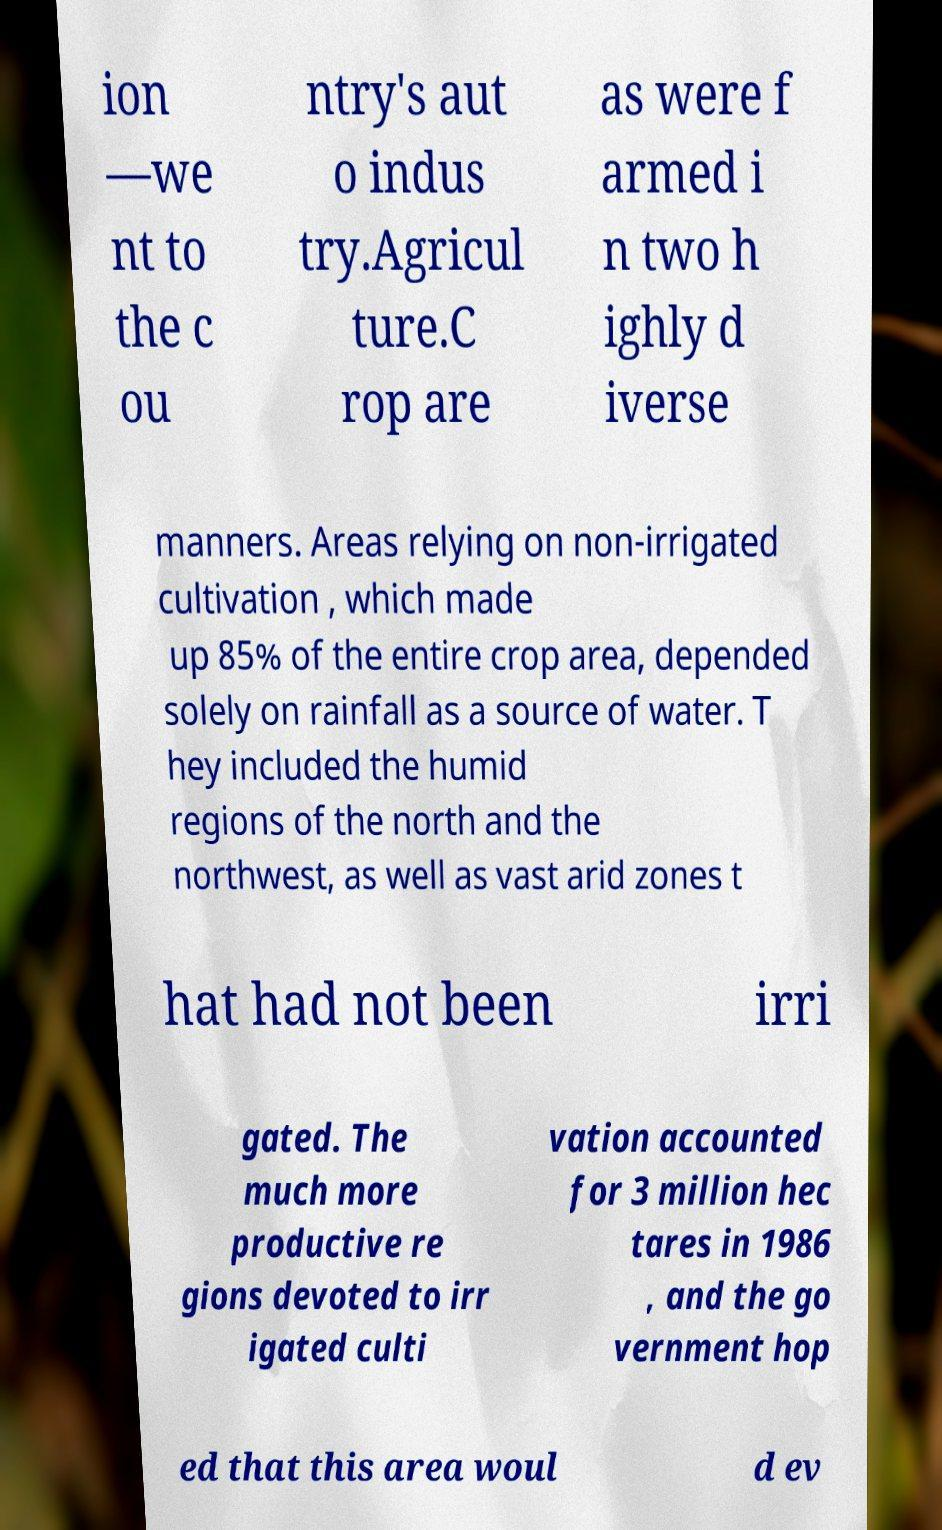Could you extract and type out the text from this image? ion —we nt to the c ou ntry's aut o indus try.Agricul ture.C rop are as were f armed i n two h ighly d iverse manners. Areas relying on non-irrigated cultivation , which made up 85% of the entire crop area, depended solely on rainfall as a source of water. T hey included the humid regions of the north and the northwest, as well as vast arid zones t hat had not been irri gated. The much more productive re gions devoted to irr igated culti vation accounted for 3 million hec tares in 1986 , and the go vernment hop ed that this area woul d ev 